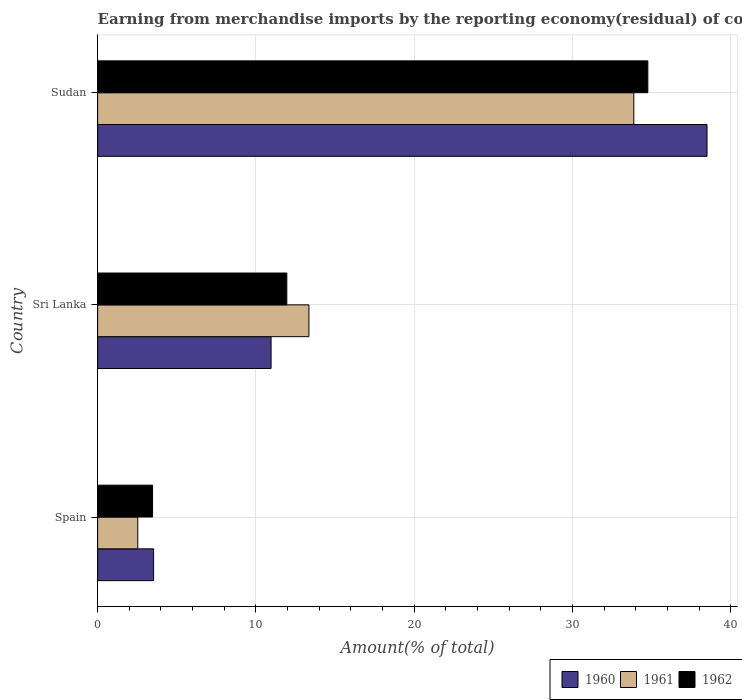How many groups of bars are there?
Your answer should be very brief. 3. Are the number of bars on each tick of the Y-axis equal?
Make the answer very short. Yes. How many bars are there on the 2nd tick from the top?
Your response must be concise. 3. What is the label of the 1st group of bars from the top?
Give a very brief answer. Sudan. In how many cases, is the number of bars for a given country not equal to the number of legend labels?
Your answer should be compact. 0. What is the percentage of amount earned from merchandise imports in 1961 in Spain?
Offer a very short reply. 2.54. Across all countries, what is the maximum percentage of amount earned from merchandise imports in 1961?
Offer a very short reply. 33.88. Across all countries, what is the minimum percentage of amount earned from merchandise imports in 1961?
Make the answer very short. 2.54. In which country was the percentage of amount earned from merchandise imports in 1960 maximum?
Give a very brief answer. Sudan. In which country was the percentage of amount earned from merchandise imports in 1961 minimum?
Keep it short and to the point. Spain. What is the total percentage of amount earned from merchandise imports in 1961 in the graph?
Give a very brief answer. 49.76. What is the difference between the percentage of amount earned from merchandise imports in 1960 in Spain and that in Sudan?
Offer a very short reply. -34.97. What is the difference between the percentage of amount earned from merchandise imports in 1960 in Spain and the percentage of amount earned from merchandise imports in 1961 in Sudan?
Make the answer very short. -30.34. What is the average percentage of amount earned from merchandise imports in 1961 per country?
Make the answer very short. 16.59. What is the difference between the percentage of amount earned from merchandise imports in 1960 and percentage of amount earned from merchandise imports in 1962 in Sudan?
Your response must be concise. 3.74. What is the ratio of the percentage of amount earned from merchandise imports in 1962 in Sri Lanka to that in Sudan?
Keep it short and to the point. 0.34. Is the difference between the percentage of amount earned from merchandise imports in 1960 in Sri Lanka and Sudan greater than the difference between the percentage of amount earned from merchandise imports in 1962 in Sri Lanka and Sudan?
Give a very brief answer. No. What is the difference between the highest and the second highest percentage of amount earned from merchandise imports in 1962?
Your answer should be very brief. 22.81. What is the difference between the highest and the lowest percentage of amount earned from merchandise imports in 1962?
Provide a succinct answer. 31.29. In how many countries, is the percentage of amount earned from merchandise imports in 1962 greater than the average percentage of amount earned from merchandise imports in 1962 taken over all countries?
Your response must be concise. 1. What does the 3rd bar from the top in Sudan represents?
Keep it short and to the point. 1960. What does the 3rd bar from the bottom in Sri Lanka represents?
Your answer should be compact. 1962. Is it the case that in every country, the sum of the percentage of amount earned from merchandise imports in 1961 and percentage of amount earned from merchandise imports in 1962 is greater than the percentage of amount earned from merchandise imports in 1960?
Offer a very short reply. Yes. What is the difference between two consecutive major ticks on the X-axis?
Your answer should be very brief. 10. Are the values on the major ticks of X-axis written in scientific E-notation?
Your answer should be compact. No. Does the graph contain any zero values?
Your answer should be compact. No. Does the graph contain grids?
Keep it short and to the point. Yes. How many legend labels are there?
Ensure brevity in your answer.  3. What is the title of the graph?
Keep it short and to the point. Earning from merchandise imports by the reporting economy(residual) of countries. What is the label or title of the X-axis?
Keep it short and to the point. Amount(% of total). What is the label or title of the Y-axis?
Your answer should be compact. Country. What is the Amount(% of total) of 1960 in Spain?
Provide a succinct answer. 3.54. What is the Amount(% of total) of 1961 in Spain?
Keep it short and to the point. 2.54. What is the Amount(% of total) of 1962 in Spain?
Offer a terse response. 3.47. What is the Amount(% of total) of 1960 in Sri Lanka?
Ensure brevity in your answer.  10.96. What is the Amount(% of total) of 1961 in Sri Lanka?
Your answer should be very brief. 13.35. What is the Amount(% of total) of 1962 in Sri Lanka?
Your response must be concise. 11.95. What is the Amount(% of total) in 1960 in Sudan?
Keep it short and to the point. 38.5. What is the Amount(% of total) in 1961 in Sudan?
Offer a terse response. 33.88. What is the Amount(% of total) in 1962 in Sudan?
Keep it short and to the point. 34.76. Across all countries, what is the maximum Amount(% of total) in 1960?
Offer a very short reply. 38.5. Across all countries, what is the maximum Amount(% of total) in 1961?
Your answer should be compact. 33.88. Across all countries, what is the maximum Amount(% of total) in 1962?
Offer a very short reply. 34.76. Across all countries, what is the minimum Amount(% of total) in 1960?
Offer a very short reply. 3.54. Across all countries, what is the minimum Amount(% of total) in 1961?
Offer a terse response. 2.54. Across all countries, what is the minimum Amount(% of total) of 1962?
Provide a succinct answer. 3.47. What is the total Amount(% of total) in 1960 in the graph?
Offer a terse response. 53. What is the total Amount(% of total) in 1961 in the graph?
Give a very brief answer. 49.76. What is the total Amount(% of total) in 1962 in the graph?
Offer a very short reply. 50.19. What is the difference between the Amount(% of total) of 1960 in Spain and that in Sri Lanka?
Ensure brevity in your answer.  -7.42. What is the difference between the Amount(% of total) in 1961 in Spain and that in Sri Lanka?
Ensure brevity in your answer.  -10.81. What is the difference between the Amount(% of total) of 1962 in Spain and that in Sri Lanka?
Your answer should be very brief. -8.48. What is the difference between the Amount(% of total) of 1960 in Spain and that in Sudan?
Provide a short and direct response. -34.97. What is the difference between the Amount(% of total) in 1961 in Spain and that in Sudan?
Your answer should be very brief. -31.34. What is the difference between the Amount(% of total) in 1962 in Spain and that in Sudan?
Your response must be concise. -31.29. What is the difference between the Amount(% of total) in 1960 in Sri Lanka and that in Sudan?
Your response must be concise. -27.55. What is the difference between the Amount(% of total) of 1961 in Sri Lanka and that in Sudan?
Make the answer very short. -20.53. What is the difference between the Amount(% of total) in 1962 in Sri Lanka and that in Sudan?
Keep it short and to the point. -22.81. What is the difference between the Amount(% of total) of 1960 in Spain and the Amount(% of total) of 1961 in Sri Lanka?
Offer a terse response. -9.81. What is the difference between the Amount(% of total) in 1960 in Spain and the Amount(% of total) in 1962 in Sri Lanka?
Offer a terse response. -8.42. What is the difference between the Amount(% of total) of 1961 in Spain and the Amount(% of total) of 1962 in Sri Lanka?
Your response must be concise. -9.42. What is the difference between the Amount(% of total) of 1960 in Spain and the Amount(% of total) of 1961 in Sudan?
Your response must be concise. -30.34. What is the difference between the Amount(% of total) in 1960 in Spain and the Amount(% of total) in 1962 in Sudan?
Keep it short and to the point. -31.23. What is the difference between the Amount(% of total) in 1961 in Spain and the Amount(% of total) in 1962 in Sudan?
Make the answer very short. -32.23. What is the difference between the Amount(% of total) of 1960 in Sri Lanka and the Amount(% of total) of 1961 in Sudan?
Your answer should be compact. -22.92. What is the difference between the Amount(% of total) in 1960 in Sri Lanka and the Amount(% of total) in 1962 in Sudan?
Give a very brief answer. -23.8. What is the difference between the Amount(% of total) of 1961 in Sri Lanka and the Amount(% of total) of 1962 in Sudan?
Give a very brief answer. -21.41. What is the average Amount(% of total) of 1960 per country?
Offer a very short reply. 17.67. What is the average Amount(% of total) of 1961 per country?
Your answer should be compact. 16.59. What is the average Amount(% of total) in 1962 per country?
Your answer should be compact. 16.73. What is the difference between the Amount(% of total) of 1960 and Amount(% of total) of 1962 in Spain?
Your answer should be very brief. 0.07. What is the difference between the Amount(% of total) of 1961 and Amount(% of total) of 1962 in Spain?
Offer a very short reply. -0.94. What is the difference between the Amount(% of total) in 1960 and Amount(% of total) in 1961 in Sri Lanka?
Offer a very short reply. -2.39. What is the difference between the Amount(% of total) of 1960 and Amount(% of total) of 1962 in Sri Lanka?
Ensure brevity in your answer.  -0.99. What is the difference between the Amount(% of total) of 1961 and Amount(% of total) of 1962 in Sri Lanka?
Your answer should be very brief. 1.4. What is the difference between the Amount(% of total) in 1960 and Amount(% of total) in 1961 in Sudan?
Your answer should be very brief. 4.63. What is the difference between the Amount(% of total) of 1960 and Amount(% of total) of 1962 in Sudan?
Keep it short and to the point. 3.74. What is the difference between the Amount(% of total) in 1961 and Amount(% of total) in 1962 in Sudan?
Ensure brevity in your answer.  -0.89. What is the ratio of the Amount(% of total) of 1960 in Spain to that in Sri Lanka?
Ensure brevity in your answer.  0.32. What is the ratio of the Amount(% of total) of 1961 in Spain to that in Sri Lanka?
Your answer should be compact. 0.19. What is the ratio of the Amount(% of total) of 1962 in Spain to that in Sri Lanka?
Offer a terse response. 0.29. What is the ratio of the Amount(% of total) of 1960 in Spain to that in Sudan?
Keep it short and to the point. 0.09. What is the ratio of the Amount(% of total) in 1961 in Spain to that in Sudan?
Your answer should be very brief. 0.07. What is the ratio of the Amount(% of total) of 1962 in Spain to that in Sudan?
Offer a terse response. 0.1. What is the ratio of the Amount(% of total) of 1960 in Sri Lanka to that in Sudan?
Your answer should be compact. 0.28. What is the ratio of the Amount(% of total) of 1961 in Sri Lanka to that in Sudan?
Provide a short and direct response. 0.39. What is the ratio of the Amount(% of total) in 1962 in Sri Lanka to that in Sudan?
Keep it short and to the point. 0.34. What is the difference between the highest and the second highest Amount(% of total) of 1960?
Keep it short and to the point. 27.55. What is the difference between the highest and the second highest Amount(% of total) in 1961?
Provide a short and direct response. 20.53. What is the difference between the highest and the second highest Amount(% of total) of 1962?
Your answer should be compact. 22.81. What is the difference between the highest and the lowest Amount(% of total) of 1960?
Make the answer very short. 34.97. What is the difference between the highest and the lowest Amount(% of total) of 1961?
Make the answer very short. 31.34. What is the difference between the highest and the lowest Amount(% of total) of 1962?
Make the answer very short. 31.29. 